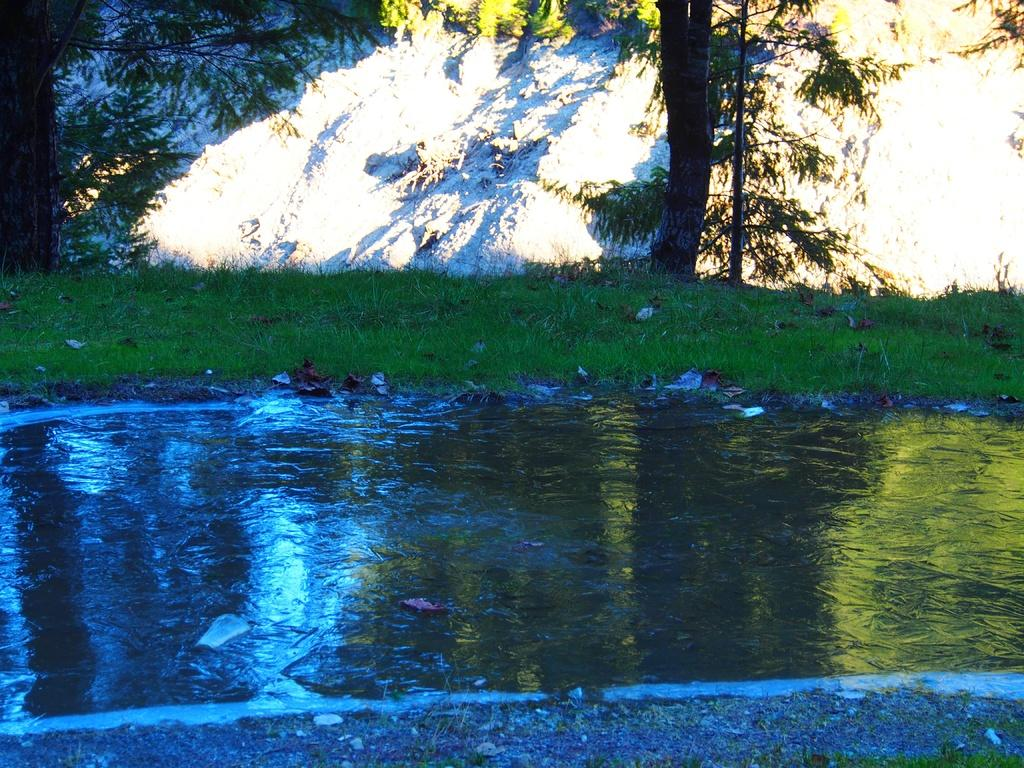What is the primary element visible in the image? There is water in the image. What type of vegetation can be seen in the image? There is grass and trees in the image. Can you describe any other objects or features in the background of the image? There is a rock visible in the background of the image. How much science is being conducted in the image? There is no indication of any scientific activity in the image. Can you tell me when the birth of the trees occurred in the image? The image does not provide information about the birth or age of the trees. 